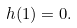<formula> <loc_0><loc_0><loc_500><loc_500>h ( 1 ) = 0 .</formula> 